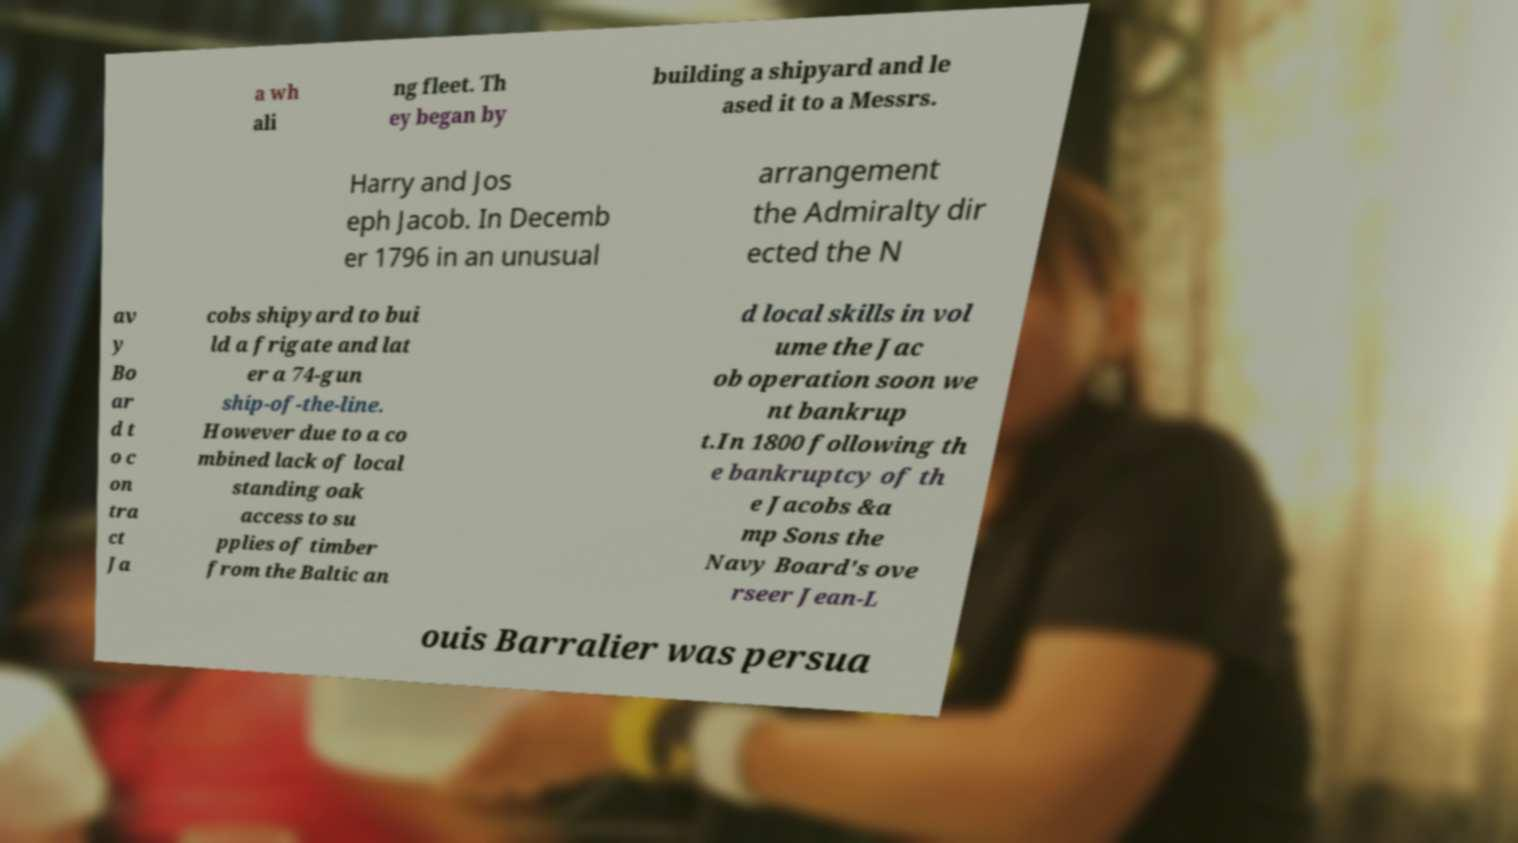There's text embedded in this image that I need extracted. Can you transcribe it verbatim? a wh ali ng fleet. Th ey began by building a shipyard and le ased it to a Messrs. Harry and Jos eph Jacob. In Decemb er 1796 in an unusual arrangement the Admiralty dir ected the N av y Bo ar d t o c on tra ct Ja cobs shipyard to bui ld a frigate and lat er a 74-gun ship-of-the-line. However due to a co mbined lack of local standing oak access to su pplies of timber from the Baltic an d local skills in vol ume the Jac ob operation soon we nt bankrup t.In 1800 following th e bankruptcy of th e Jacobs &a mp Sons the Navy Board's ove rseer Jean-L ouis Barralier was persua 